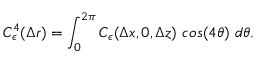<formula> <loc_0><loc_0><loc_500><loc_500>C _ { \epsilon } ^ { 4 } ( \Delta r ) = \int _ { 0 } ^ { 2 \pi } C _ { \epsilon } ( \Delta x , 0 , \Delta z ) \cos ( 4 \theta ) d \theta .</formula> 